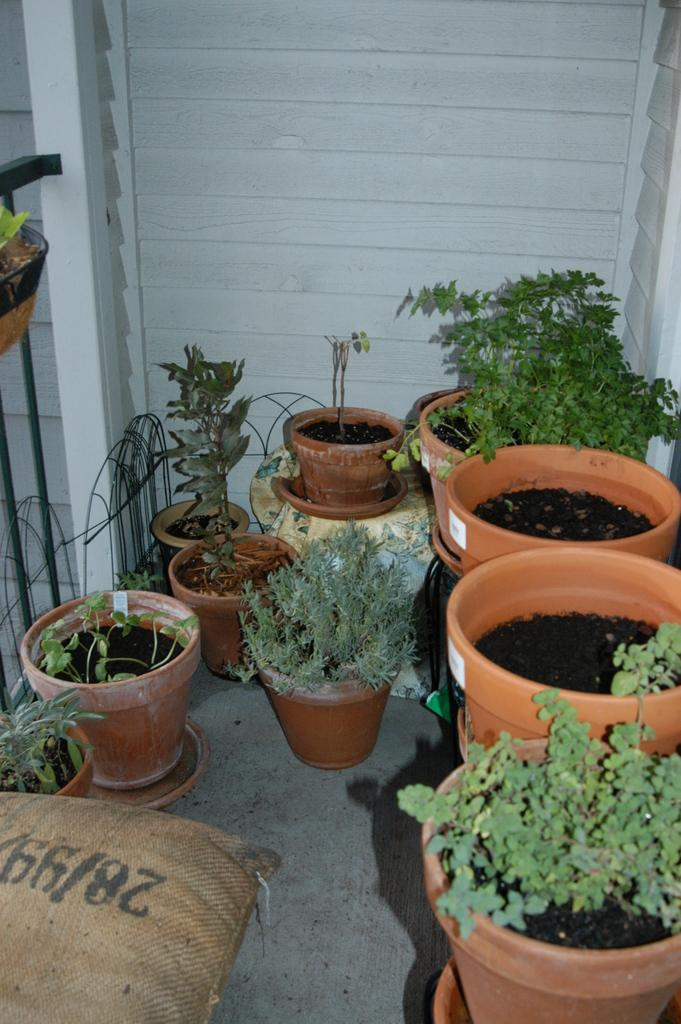What type of plants are in the image? There are house plants in the image. Where are the house plants located? The house plants are placed on the floor. What can be seen in the bottom left of the image? There is a bag in the bottom left of the image. What is visible in the background of the image? There is a wall in the background of the image. What type of tax can be seen being paid in the image? There is no tax being paid in the image; it features house plants on the floor, a bag in the bottom left, and a wall in the background. 